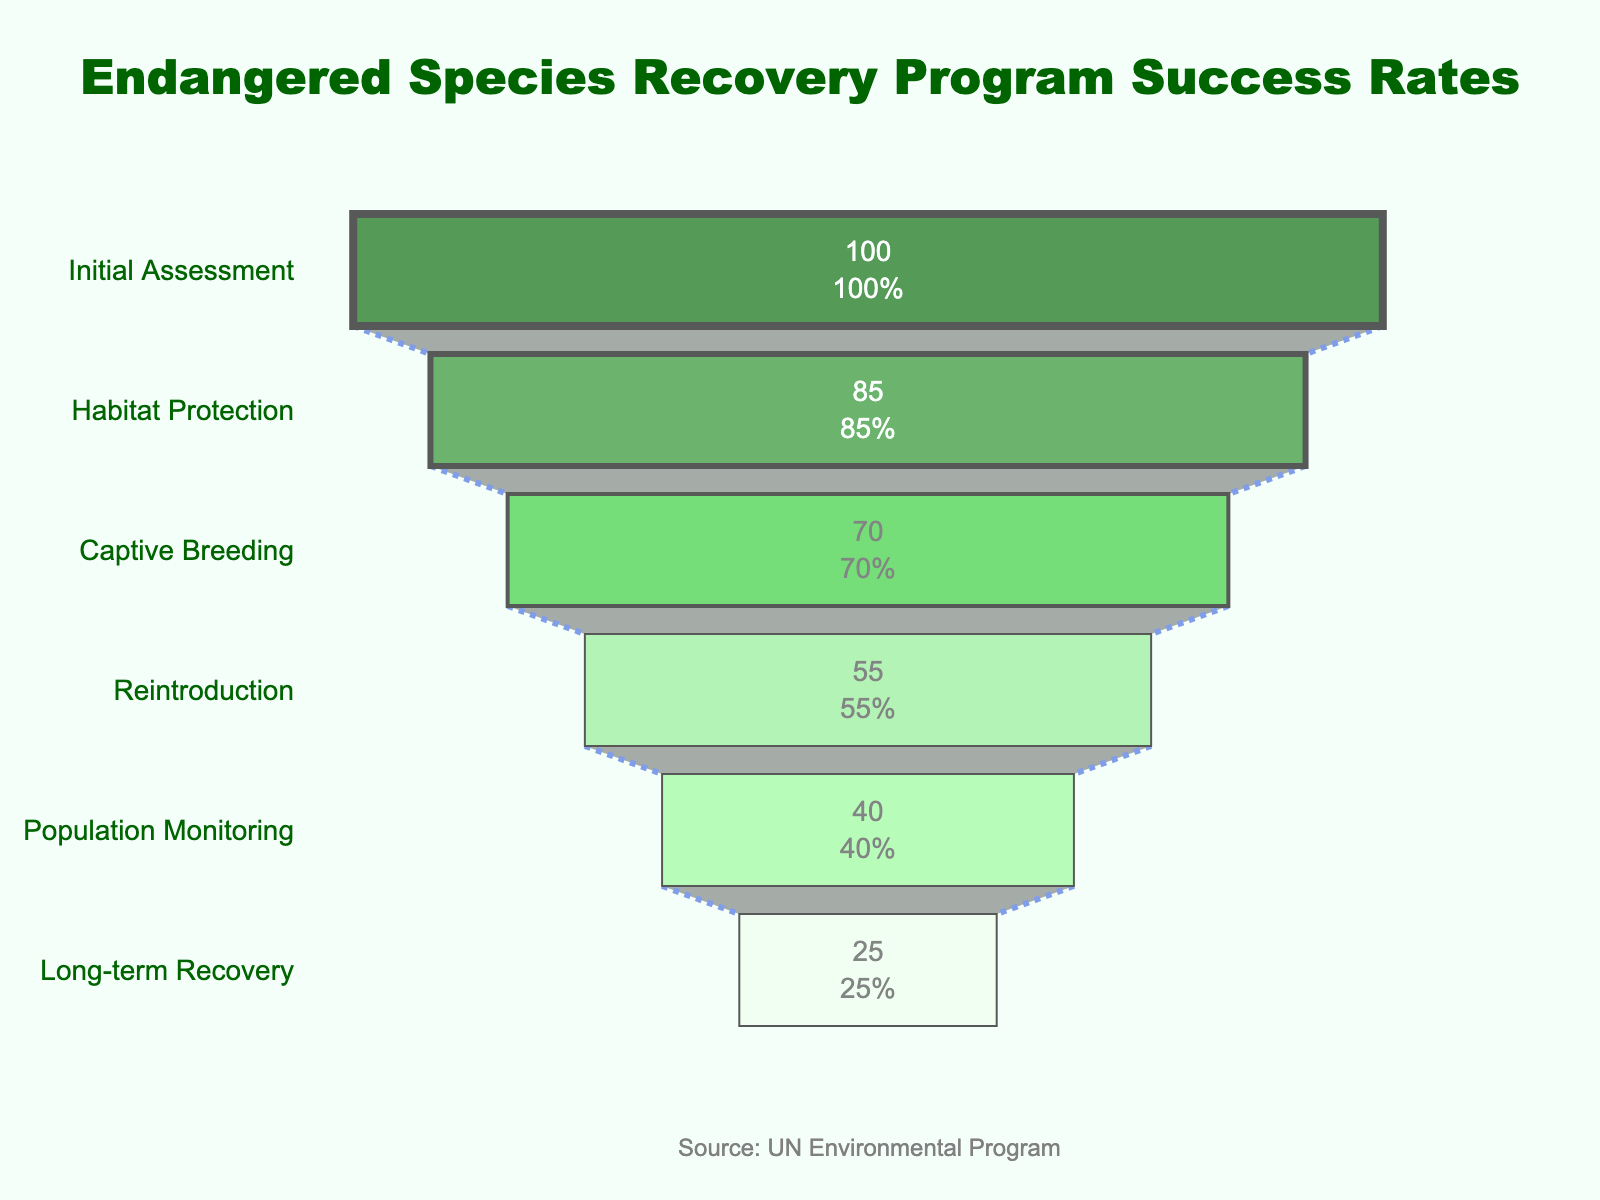What is the title of the funnel chart? The title of the funnel chart is displayed at the top in a bold, dark green font. By observing the visual layout, the title can be read directly.
Answer: Endangered Species Recovery Program Success Rates What stage has the highest success rate? In a funnel chart, the top segment represents the highest success rate, which is typically the widest part. By reading the y-axis label of the top stage, we find the stage with the highest success rate.
Answer: Initial Assessment By how much does the success rate drop from Initial Assessment to Habitat Protection? To compute the drop, subtract the success rate of Habitat Protection (85) from the success rate of the Initial Assessment (100).
Answer: 15 What is the combined success rate of the Captive Breeding and Population Monitoring stages? To find the combined success rate, add the success rates of Captive Breeding (70) and Population Monitoring (40).
Answer: 110 Which stage has a larger success rate, Reintroduction or Long-term Recovery? Compare the success rates of Reintroduction (55) and Long-term Recovery (25). By observing, Reintroduction has a higher success rate.
Answer: Reintroduction Describe the color pattern used in the funnel chart. The funnel chart uses varying shades of green moving from darker green at the top to lighter green at the bottom. Each stage has a distinct shade starting from '#006400' to '#F0FFF0'.
Answer: Dark to light green Is the success rate of Population Monitoring more than half of the Initial Assessment? Check if half of Initial Assessment’s rate (100) is greater than Population Monitoring's rate (40). Since half of 100 is 50, which is greater than 40, Population Monitoring’s rate is not more than half.
Answer: No How many stages have a success rate of 40 or above? Identify stages with a success rate of 40 or above by scanning the x-axis values. There are four such stages: Initial Assessment, Habitat Protection, Captive Breeding, and Reintroduction.
Answer: Four What is the success rate difference between Habitat Protection and Long-term Recovery? Subtract the success rate of Long-term Recovery (25) from Habitat Protection (85).
Answer: 60 